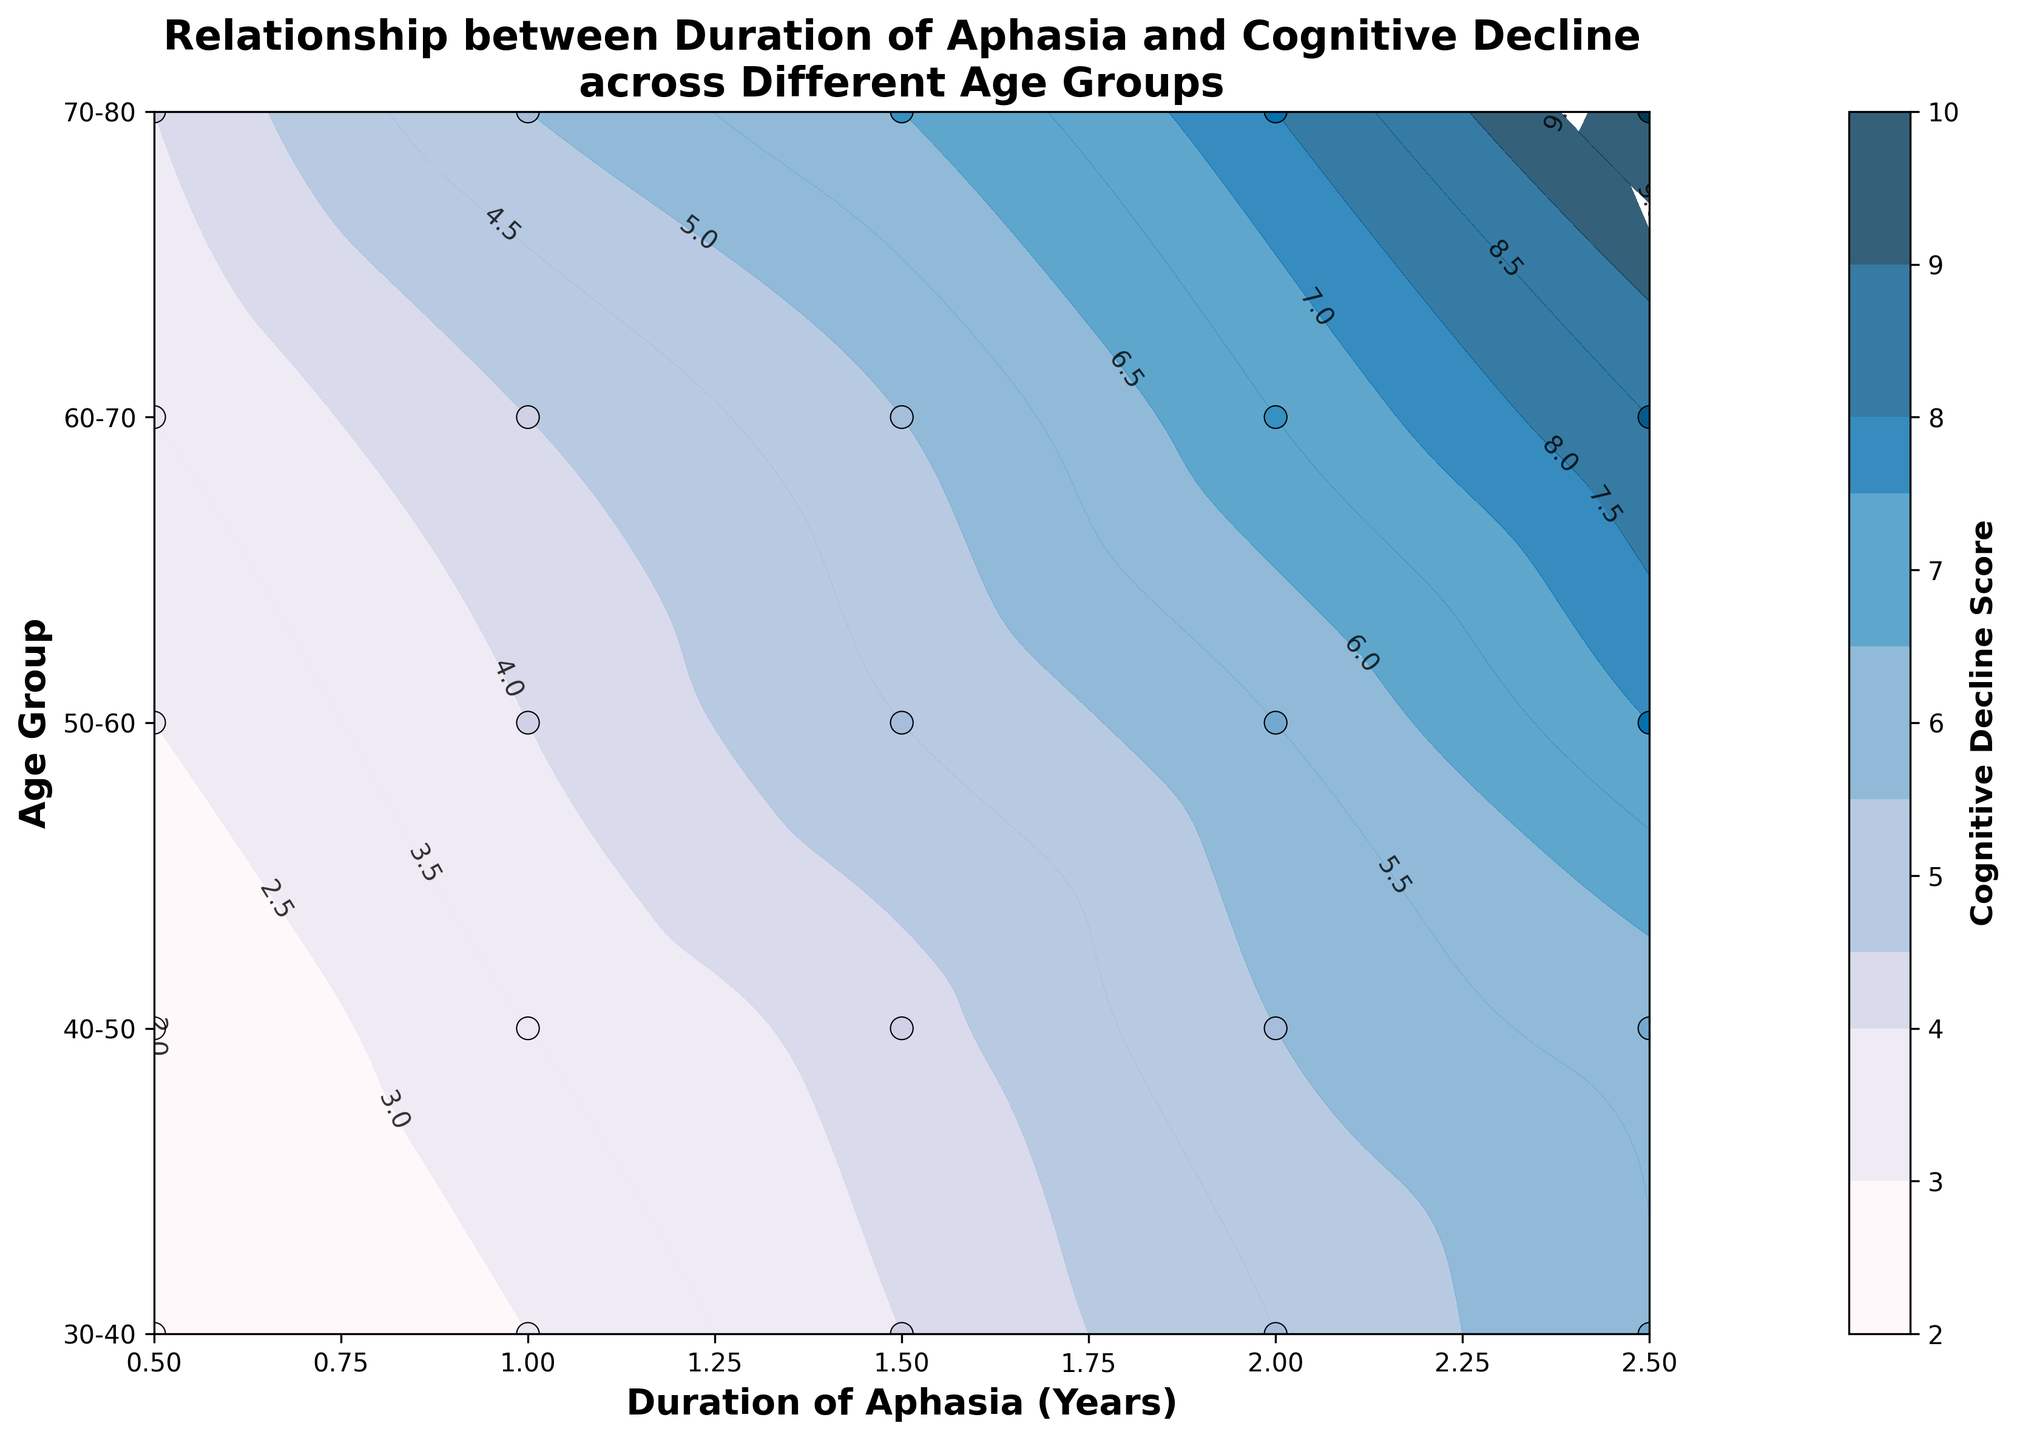What is the title of the plot? The title of the plot is written at the top of the figure. By looking at the text, we can see it is "Relationship between Duration of Aphasia and Cognitive Decline across Different Age Groups".
Answer: Relationship between Duration of Aphasia and Cognitive Decline across Different Age Groups What are the labels of the x and y axes? Axis labels are found directly next to the respective axes. The x-axis is labeled "Duration of Aphasia (Years)" and the y-axis is labeled "Age Group".
Answer: Duration of Aphasia (Years), Age Group Which age group shows the highest cognitive decline score at 1 year of aphasia? By looking at the contour lines and scatter points corresponding to 1 year of aphasia, we observe the highest score near the 70-80 age group.
Answer: 70-80 What is the cognitive decline score for the 50-60 age group at 2.5 years of aphasia? Locate the point where the duration is 2.5 years and align it with the age group 50-60, then look at the corresponding color gradient or contour label. It indicates a score around 7.5.
Answer: 7.5 Compare the cognitive decline scores between age groups 40-50 and 50-60 at 1.5 years of aphasia. Which is higher? Find the points on the plot where the duration is 1.5 years for both age groups. The contour lines or colors indicate that 50-60 has a score of 5, while 40-50 has a score of 4.3. Hence, 50-60 has a higher score.
Answer: 50-60 How does the cognitive decline score change between 0.5 and 2.5 years of aphasia in the 60-70 age group? Look at the contour lines from 0.5 to 2.5 years for the 60-70 age group. The scores increase from 3.5 to 8.5 as the duration of aphasia increases.
Answer: Increases from 3.5 to 8.5 What can you infer about the relationship between duration of aphasia and cognitive decline in younger versus older age groups? By observing the contour plots: younger groups like 30-40 and 40-50 show a lower overall cognitive decline across durations of aphasia compared to older groups like 60-70 and 70-80, which exhibit steeper increases in cognitive decline scores as duration lengthens.
Answer: Older groups show higher cognitive decline Does the color gradient indicate higher or lower cognitive decline scores? The color gradient shifts from light to dark, with darker colors indicating higher cognitive decline scores as shown by the color legend.
Answer: Higher scores What is the range of cognitive decline scores indicated in the contour plot? The colorbar legend on the side of the plot shows the minimum and maximum values. The scores range from 2 to 10.
Answer: 2 to 10 